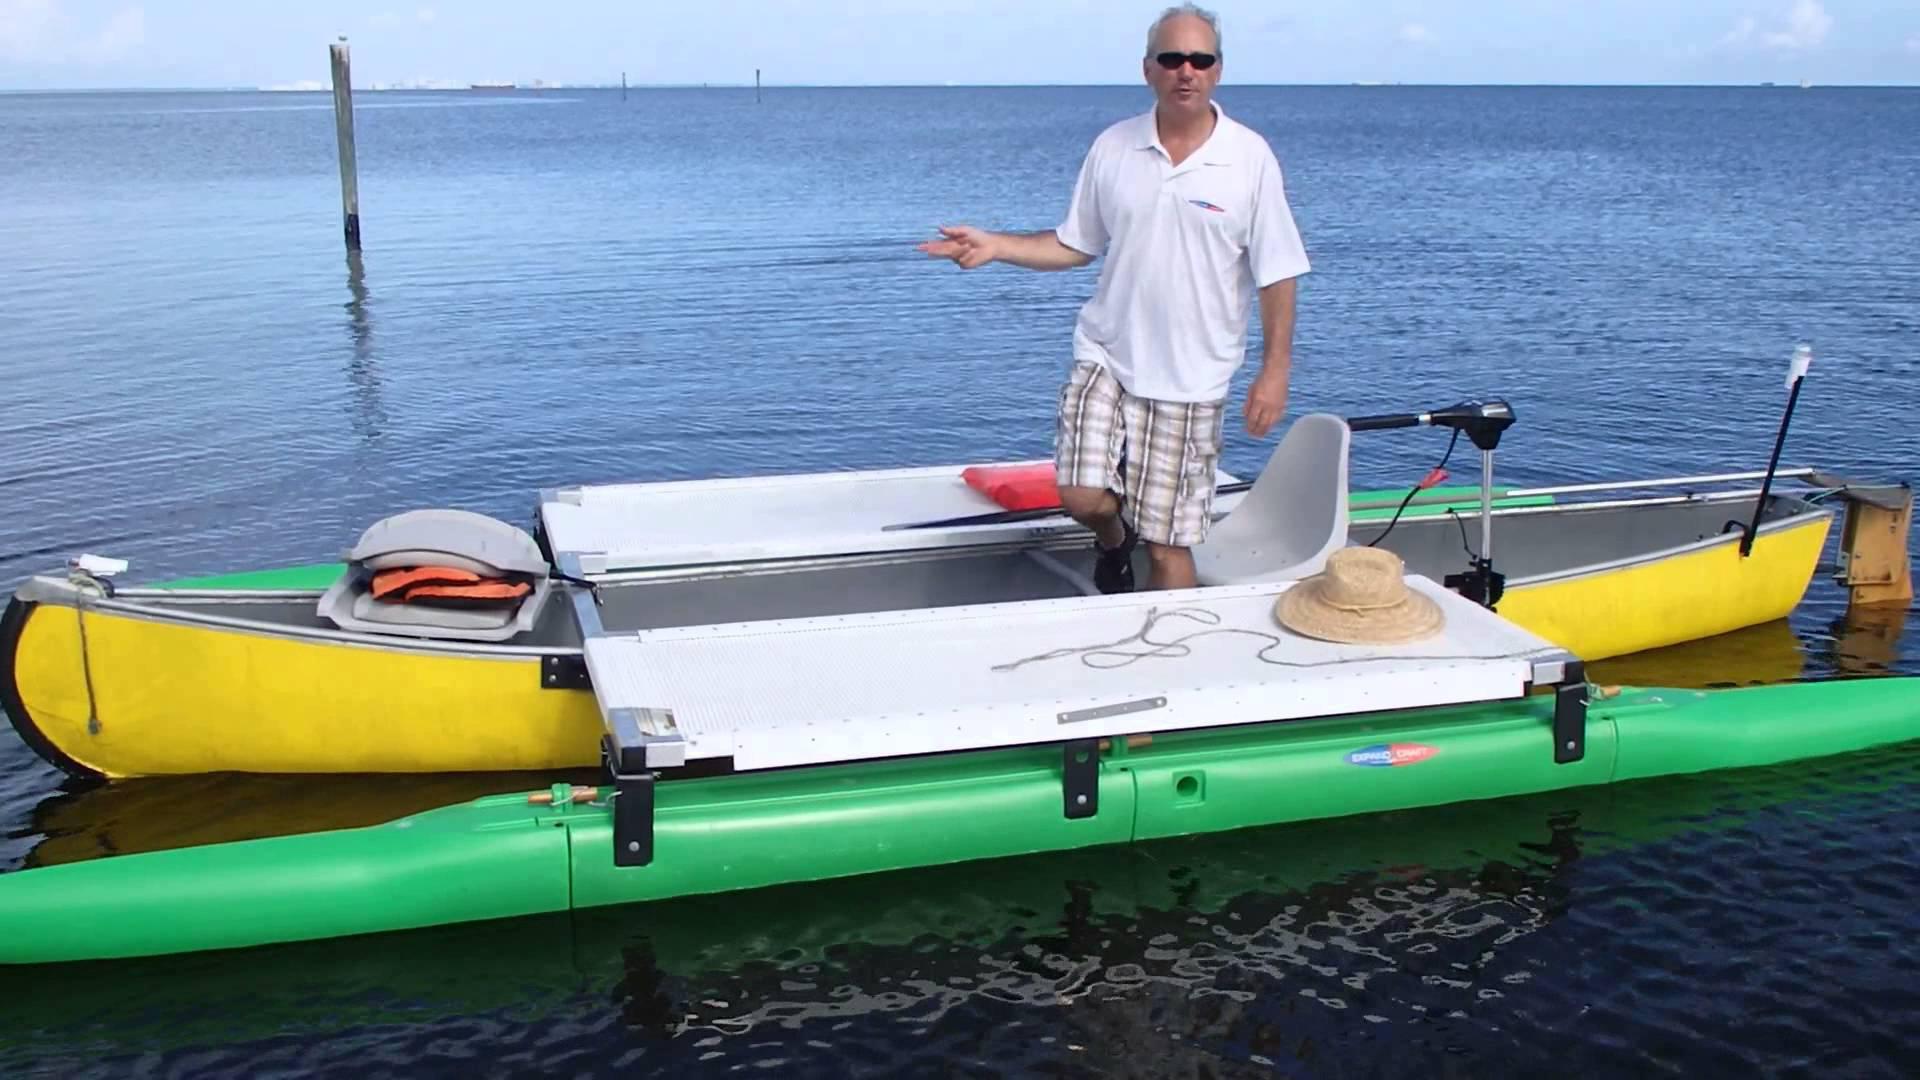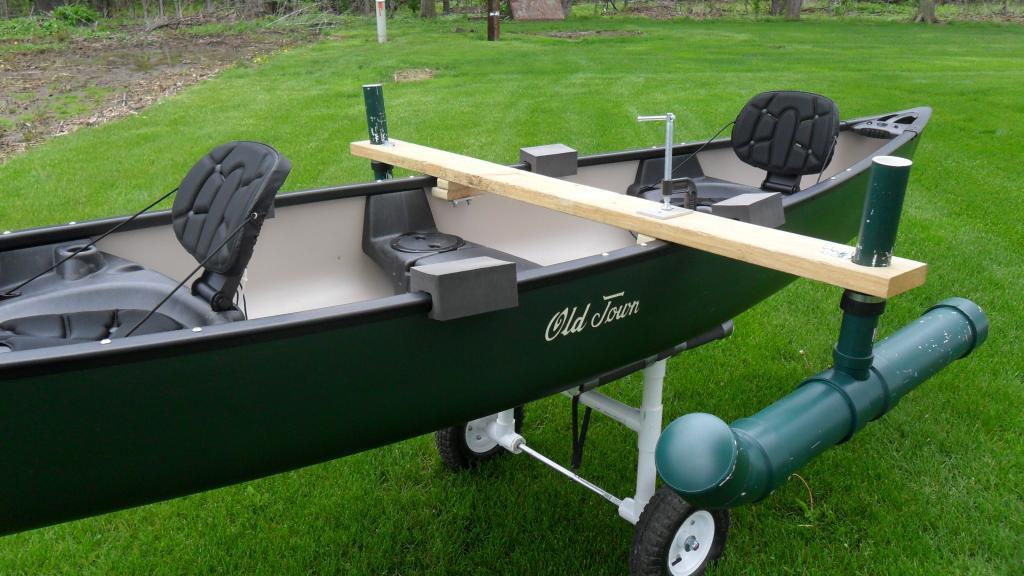The first image is the image on the left, the second image is the image on the right. Examine the images to the left and right. Is the description "An image shows at least one person in a yellow canoe on the water." accurate? Answer yes or no. Yes. The first image is the image on the left, the second image is the image on the right. Evaluate the accuracy of this statement regarding the images: "At least one person is in a boat floating on water.". Is it true? Answer yes or no. Yes. 